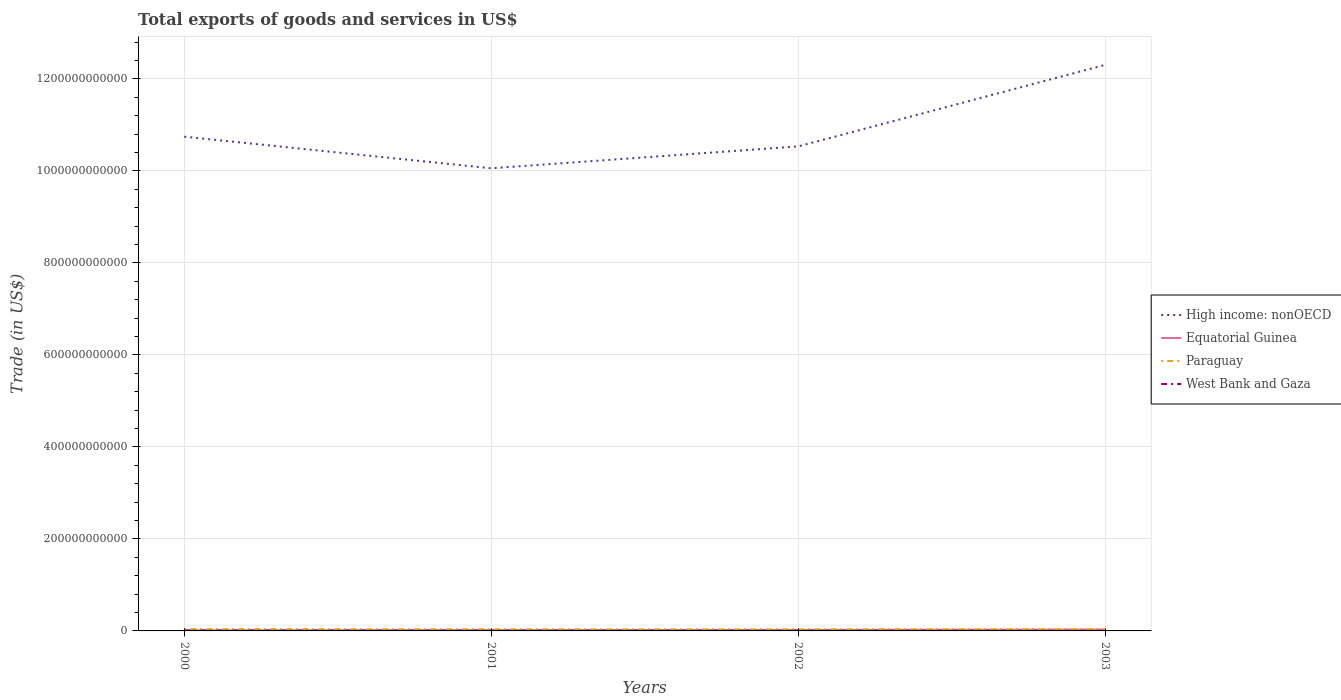Does the line corresponding to West Bank and Gaza intersect with the line corresponding to Paraguay?
Ensure brevity in your answer.  No. Is the number of lines equal to the number of legend labels?
Offer a terse response. Yes. Across all years, what is the maximum total exports of goods and services in High income: nonOECD?
Provide a short and direct response. 1.01e+12. What is the total total exports of goods and services in West Bank and Gaza in the graph?
Give a very brief answer. 4.08e+08. What is the difference between the highest and the second highest total exports of goods and services in Equatorial Guinea?
Your answer should be compact. 1.68e+09. Is the total exports of goods and services in Paraguay strictly greater than the total exports of goods and services in West Bank and Gaza over the years?
Keep it short and to the point. No. How many lines are there?
Offer a terse response. 4. What is the difference between two consecutive major ticks on the Y-axis?
Your answer should be compact. 2.00e+11. Are the values on the major ticks of Y-axis written in scientific E-notation?
Offer a terse response. No. Does the graph contain any zero values?
Ensure brevity in your answer.  No. How many legend labels are there?
Provide a short and direct response. 4. What is the title of the graph?
Your answer should be compact. Total exports of goods and services in US$. Does "Europe(all income levels)" appear as one of the legend labels in the graph?
Provide a short and direct response. No. What is the label or title of the X-axis?
Make the answer very short. Years. What is the label or title of the Y-axis?
Provide a succinct answer. Trade (in US$). What is the Trade (in US$) of High income: nonOECD in 2000?
Give a very brief answer. 1.07e+12. What is the Trade (in US$) of Equatorial Guinea in 2000?
Ensure brevity in your answer.  1.28e+09. What is the Trade (in US$) of Paraguay in 2000?
Ensure brevity in your answer.  3.84e+09. What is the Trade (in US$) in West Bank and Gaza in 2000?
Give a very brief answer. 8.86e+08. What is the Trade (in US$) of High income: nonOECD in 2001?
Provide a short and direct response. 1.01e+12. What is the Trade (in US$) in Equatorial Guinea in 2001?
Offer a very short reply. 1.82e+09. What is the Trade (in US$) in Paraguay in 2001?
Ensure brevity in your answer.  3.46e+09. What is the Trade (in US$) in West Bank and Gaza in 2001?
Your response must be concise. 6.17e+08. What is the Trade (in US$) in High income: nonOECD in 2002?
Ensure brevity in your answer.  1.05e+12. What is the Trade (in US$) in Equatorial Guinea in 2002?
Ensure brevity in your answer.  2.21e+09. What is the Trade (in US$) in Paraguay in 2002?
Provide a short and direct response. 3.40e+09. What is the Trade (in US$) of West Bank and Gaza in 2002?
Your response must be concise. 4.78e+08. What is the Trade (in US$) of High income: nonOECD in 2003?
Your response must be concise. 1.23e+12. What is the Trade (in US$) of Equatorial Guinea in 2003?
Offer a very short reply. 2.95e+09. What is the Trade (in US$) in Paraguay in 2003?
Provide a short and direct response. 3.63e+09. What is the Trade (in US$) of West Bank and Gaza in 2003?
Offer a terse response. 5.14e+08. Across all years, what is the maximum Trade (in US$) in High income: nonOECD?
Give a very brief answer. 1.23e+12. Across all years, what is the maximum Trade (in US$) in Equatorial Guinea?
Give a very brief answer. 2.95e+09. Across all years, what is the maximum Trade (in US$) of Paraguay?
Your response must be concise. 3.84e+09. Across all years, what is the maximum Trade (in US$) of West Bank and Gaza?
Your response must be concise. 8.86e+08. Across all years, what is the minimum Trade (in US$) in High income: nonOECD?
Make the answer very short. 1.01e+12. Across all years, what is the minimum Trade (in US$) in Equatorial Guinea?
Offer a terse response. 1.28e+09. Across all years, what is the minimum Trade (in US$) in Paraguay?
Keep it short and to the point. 3.40e+09. Across all years, what is the minimum Trade (in US$) of West Bank and Gaza?
Your answer should be very brief. 4.78e+08. What is the total Trade (in US$) of High income: nonOECD in the graph?
Offer a very short reply. 4.36e+12. What is the total Trade (in US$) of Equatorial Guinea in the graph?
Your response must be concise. 8.26e+09. What is the total Trade (in US$) of Paraguay in the graph?
Ensure brevity in your answer.  1.43e+1. What is the total Trade (in US$) of West Bank and Gaza in the graph?
Your response must be concise. 2.49e+09. What is the difference between the Trade (in US$) of High income: nonOECD in 2000 and that in 2001?
Your answer should be compact. 6.87e+1. What is the difference between the Trade (in US$) of Equatorial Guinea in 2000 and that in 2001?
Provide a short and direct response. -5.41e+08. What is the difference between the Trade (in US$) of Paraguay in 2000 and that in 2001?
Provide a succinct answer. 3.80e+08. What is the difference between the Trade (in US$) of West Bank and Gaza in 2000 and that in 2001?
Provide a succinct answer. 2.69e+08. What is the difference between the Trade (in US$) of High income: nonOECD in 2000 and that in 2002?
Your answer should be compact. 2.11e+1. What is the difference between the Trade (in US$) of Equatorial Guinea in 2000 and that in 2002?
Provide a short and direct response. -9.32e+08. What is the difference between the Trade (in US$) of Paraguay in 2000 and that in 2002?
Your answer should be very brief. 4.36e+08. What is the difference between the Trade (in US$) of West Bank and Gaza in 2000 and that in 2002?
Give a very brief answer. 4.08e+08. What is the difference between the Trade (in US$) in High income: nonOECD in 2000 and that in 2003?
Your answer should be compact. -1.56e+11. What is the difference between the Trade (in US$) of Equatorial Guinea in 2000 and that in 2003?
Provide a short and direct response. -1.68e+09. What is the difference between the Trade (in US$) of Paraguay in 2000 and that in 2003?
Keep it short and to the point. 2.13e+08. What is the difference between the Trade (in US$) in West Bank and Gaza in 2000 and that in 2003?
Make the answer very short. 3.72e+08. What is the difference between the Trade (in US$) of High income: nonOECD in 2001 and that in 2002?
Provide a short and direct response. -4.76e+1. What is the difference between the Trade (in US$) of Equatorial Guinea in 2001 and that in 2002?
Your answer should be compact. -3.91e+08. What is the difference between the Trade (in US$) of Paraguay in 2001 and that in 2002?
Your response must be concise. 5.65e+07. What is the difference between the Trade (in US$) in West Bank and Gaza in 2001 and that in 2002?
Ensure brevity in your answer.  1.39e+08. What is the difference between the Trade (in US$) of High income: nonOECD in 2001 and that in 2003?
Offer a terse response. -2.25e+11. What is the difference between the Trade (in US$) in Equatorial Guinea in 2001 and that in 2003?
Provide a succinct answer. -1.14e+09. What is the difference between the Trade (in US$) in Paraguay in 2001 and that in 2003?
Ensure brevity in your answer.  -1.67e+08. What is the difference between the Trade (in US$) of West Bank and Gaza in 2001 and that in 2003?
Keep it short and to the point. 1.03e+08. What is the difference between the Trade (in US$) of High income: nonOECD in 2002 and that in 2003?
Give a very brief answer. -1.77e+11. What is the difference between the Trade (in US$) in Equatorial Guinea in 2002 and that in 2003?
Provide a short and direct response. -7.44e+08. What is the difference between the Trade (in US$) of Paraguay in 2002 and that in 2003?
Your response must be concise. -2.23e+08. What is the difference between the Trade (in US$) in West Bank and Gaza in 2002 and that in 2003?
Your answer should be very brief. -3.59e+07. What is the difference between the Trade (in US$) of High income: nonOECD in 2000 and the Trade (in US$) of Equatorial Guinea in 2001?
Your response must be concise. 1.07e+12. What is the difference between the Trade (in US$) in High income: nonOECD in 2000 and the Trade (in US$) in Paraguay in 2001?
Ensure brevity in your answer.  1.07e+12. What is the difference between the Trade (in US$) in High income: nonOECD in 2000 and the Trade (in US$) in West Bank and Gaza in 2001?
Your answer should be very brief. 1.07e+12. What is the difference between the Trade (in US$) in Equatorial Guinea in 2000 and the Trade (in US$) in Paraguay in 2001?
Offer a very short reply. -2.18e+09. What is the difference between the Trade (in US$) in Equatorial Guinea in 2000 and the Trade (in US$) in West Bank and Gaza in 2001?
Ensure brevity in your answer.  6.60e+08. What is the difference between the Trade (in US$) in Paraguay in 2000 and the Trade (in US$) in West Bank and Gaza in 2001?
Keep it short and to the point. 3.22e+09. What is the difference between the Trade (in US$) in High income: nonOECD in 2000 and the Trade (in US$) in Equatorial Guinea in 2002?
Your response must be concise. 1.07e+12. What is the difference between the Trade (in US$) of High income: nonOECD in 2000 and the Trade (in US$) of Paraguay in 2002?
Your answer should be compact. 1.07e+12. What is the difference between the Trade (in US$) of High income: nonOECD in 2000 and the Trade (in US$) of West Bank and Gaza in 2002?
Your answer should be very brief. 1.07e+12. What is the difference between the Trade (in US$) of Equatorial Guinea in 2000 and the Trade (in US$) of Paraguay in 2002?
Your response must be concise. -2.13e+09. What is the difference between the Trade (in US$) of Equatorial Guinea in 2000 and the Trade (in US$) of West Bank and Gaza in 2002?
Your answer should be very brief. 7.99e+08. What is the difference between the Trade (in US$) in Paraguay in 2000 and the Trade (in US$) in West Bank and Gaza in 2002?
Your response must be concise. 3.36e+09. What is the difference between the Trade (in US$) of High income: nonOECD in 2000 and the Trade (in US$) of Equatorial Guinea in 2003?
Provide a succinct answer. 1.07e+12. What is the difference between the Trade (in US$) in High income: nonOECD in 2000 and the Trade (in US$) in Paraguay in 2003?
Ensure brevity in your answer.  1.07e+12. What is the difference between the Trade (in US$) in High income: nonOECD in 2000 and the Trade (in US$) in West Bank and Gaza in 2003?
Keep it short and to the point. 1.07e+12. What is the difference between the Trade (in US$) of Equatorial Guinea in 2000 and the Trade (in US$) of Paraguay in 2003?
Provide a short and direct response. -2.35e+09. What is the difference between the Trade (in US$) in Equatorial Guinea in 2000 and the Trade (in US$) in West Bank and Gaza in 2003?
Provide a short and direct response. 7.63e+08. What is the difference between the Trade (in US$) in Paraguay in 2000 and the Trade (in US$) in West Bank and Gaza in 2003?
Make the answer very short. 3.33e+09. What is the difference between the Trade (in US$) of High income: nonOECD in 2001 and the Trade (in US$) of Equatorial Guinea in 2002?
Provide a short and direct response. 1.00e+12. What is the difference between the Trade (in US$) of High income: nonOECD in 2001 and the Trade (in US$) of Paraguay in 2002?
Provide a short and direct response. 1.00e+12. What is the difference between the Trade (in US$) in High income: nonOECD in 2001 and the Trade (in US$) in West Bank and Gaza in 2002?
Ensure brevity in your answer.  1.01e+12. What is the difference between the Trade (in US$) of Equatorial Guinea in 2001 and the Trade (in US$) of Paraguay in 2002?
Your answer should be very brief. -1.59e+09. What is the difference between the Trade (in US$) of Equatorial Guinea in 2001 and the Trade (in US$) of West Bank and Gaza in 2002?
Your answer should be very brief. 1.34e+09. What is the difference between the Trade (in US$) of Paraguay in 2001 and the Trade (in US$) of West Bank and Gaza in 2002?
Ensure brevity in your answer.  2.98e+09. What is the difference between the Trade (in US$) in High income: nonOECD in 2001 and the Trade (in US$) in Equatorial Guinea in 2003?
Provide a short and direct response. 1.00e+12. What is the difference between the Trade (in US$) in High income: nonOECD in 2001 and the Trade (in US$) in Paraguay in 2003?
Your answer should be very brief. 1.00e+12. What is the difference between the Trade (in US$) of High income: nonOECD in 2001 and the Trade (in US$) of West Bank and Gaza in 2003?
Provide a short and direct response. 1.01e+12. What is the difference between the Trade (in US$) of Equatorial Guinea in 2001 and the Trade (in US$) of Paraguay in 2003?
Ensure brevity in your answer.  -1.81e+09. What is the difference between the Trade (in US$) of Equatorial Guinea in 2001 and the Trade (in US$) of West Bank and Gaza in 2003?
Ensure brevity in your answer.  1.30e+09. What is the difference between the Trade (in US$) of Paraguay in 2001 and the Trade (in US$) of West Bank and Gaza in 2003?
Your answer should be compact. 2.95e+09. What is the difference between the Trade (in US$) in High income: nonOECD in 2002 and the Trade (in US$) in Equatorial Guinea in 2003?
Your answer should be compact. 1.05e+12. What is the difference between the Trade (in US$) in High income: nonOECD in 2002 and the Trade (in US$) in Paraguay in 2003?
Make the answer very short. 1.05e+12. What is the difference between the Trade (in US$) of High income: nonOECD in 2002 and the Trade (in US$) of West Bank and Gaza in 2003?
Your response must be concise. 1.05e+12. What is the difference between the Trade (in US$) of Equatorial Guinea in 2002 and the Trade (in US$) of Paraguay in 2003?
Keep it short and to the point. -1.42e+09. What is the difference between the Trade (in US$) of Equatorial Guinea in 2002 and the Trade (in US$) of West Bank and Gaza in 2003?
Your answer should be very brief. 1.70e+09. What is the difference between the Trade (in US$) of Paraguay in 2002 and the Trade (in US$) of West Bank and Gaza in 2003?
Offer a very short reply. 2.89e+09. What is the average Trade (in US$) in High income: nonOECD per year?
Offer a very short reply. 1.09e+12. What is the average Trade (in US$) in Equatorial Guinea per year?
Ensure brevity in your answer.  2.06e+09. What is the average Trade (in US$) in Paraguay per year?
Provide a succinct answer. 3.58e+09. What is the average Trade (in US$) in West Bank and Gaza per year?
Provide a succinct answer. 6.24e+08. In the year 2000, what is the difference between the Trade (in US$) of High income: nonOECD and Trade (in US$) of Equatorial Guinea?
Your answer should be very brief. 1.07e+12. In the year 2000, what is the difference between the Trade (in US$) in High income: nonOECD and Trade (in US$) in Paraguay?
Give a very brief answer. 1.07e+12. In the year 2000, what is the difference between the Trade (in US$) in High income: nonOECD and Trade (in US$) in West Bank and Gaza?
Keep it short and to the point. 1.07e+12. In the year 2000, what is the difference between the Trade (in US$) of Equatorial Guinea and Trade (in US$) of Paraguay?
Offer a terse response. -2.56e+09. In the year 2000, what is the difference between the Trade (in US$) of Equatorial Guinea and Trade (in US$) of West Bank and Gaza?
Provide a short and direct response. 3.91e+08. In the year 2000, what is the difference between the Trade (in US$) in Paraguay and Trade (in US$) in West Bank and Gaza?
Keep it short and to the point. 2.95e+09. In the year 2001, what is the difference between the Trade (in US$) in High income: nonOECD and Trade (in US$) in Equatorial Guinea?
Provide a succinct answer. 1.00e+12. In the year 2001, what is the difference between the Trade (in US$) of High income: nonOECD and Trade (in US$) of Paraguay?
Keep it short and to the point. 1.00e+12. In the year 2001, what is the difference between the Trade (in US$) in High income: nonOECD and Trade (in US$) in West Bank and Gaza?
Provide a succinct answer. 1.01e+12. In the year 2001, what is the difference between the Trade (in US$) of Equatorial Guinea and Trade (in US$) of Paraguay?
Ensure brevity in your answer.  -1.64e+09. In the year 2001, what is the difference between the Trade (in US$) in Equatorial Guinea and Trade (in US$) in West Bank and Gaza?
Provide a succinct answer. 1.20e+09. In the year 2001, what is the difference between the Trade (in US$) in Paraguay and Trade (in US$) in West Bank and Gaza?
Keep it short and to the point. 2.84e+09. In the year 2002, what is the difference between the Trade (in US$) of High income: nonOECD and Trade (in US$) of Equatorial Guinea?
Your answer should be very brief. 1.05e+12. In the year 2002, what is the difference between the Trade (in US$) in High income: nonOECD and Trade (in US$) in Paraguay?
Your answer should be very brief. 1.05e+12. In the year 2002, what is the difference between the Trade (in US$) in High income: nonOECD and Trade (in US$) in West Bank and Gaza?
Make the answer very short. 1.05e+12. In the year 2002, what is the difference between the Trade (in US$) in Equatorial Guinea and Trade (in US$) in Paraguay?
Ensure brevity in your answer.  -1.19e+09. In the year 2002, what is the difference between the Trade (in US$) of Equatorial Guinea and Trade (in US$) of West Bank and Gaza?
Ensure brevity in your answer.  1.73e+09. In the year 2002, what is the difference between the Trade (in US$) in Paraguay and Trade (in US$) in West Bank and Gaza?
Keep it short and to the point. 2.92e+09. In the year 2003, what is the difference between the Trade (in US$) in High income: nonOECD and Trade (in US$) in Equatorial Guinea?
Offer a very short reply. 1.23e+12. In the year 2003, what is the difference between the Trade (in US$) in High income: nonOECD and Trade (in US$) in Paraguay?
Ensure brevity in your answer.  1.23e+12. In the year 2003, what is the difference between the Trade (in US$) of High income: nonOECD and Trade (in US$) of West Bank and Gaza?
Your answer should be compact. 1.23e+12. In the year 2003, what is the difference between the Trade (in US$) in Equatorial Guinea and Trade (in US$) in Paraguay?
Give a very brief answer. -6.73e+08. In the year 2003, what is the difference between the Trade (in US$) in Equatorial Guinea and Trade (in US$) in West Bank and Gaza?
Ensure brevity in your answer.  2.44e+09. In the year 2003, what is the difference between the Trade (in US$) in Paraguay and Trade (in US$) in West Bank and Gaza?
Keep it short and to the point. 3.11e+09. What is the ratio of the Trade (in US$) of High income: nonOECD in 2000 to that in 2001?
Make the answer very short. 1.07. What is the ratio of the Trade (in US$) of Equatorial Guinea in 2000 to that in 2001?
Provide a short and direct response. 0.7. What is the ratio of the Trade (in US$) of Paraguay in 2000 to that in 2001?
Provide a short and direct response. 1.11. What is the ratio of the Trade (in US$) of West Bank and Gaza in 2000 to that in 2001?
Keep it short and to the point. 1.44. What is the ratio of the Trade (in US$) in High income: nonOECD in 2000 to that in 2002?
Offer a terse response. 1.02. What is the ratio of the Trade (in US$) of Equatorial Guinea in 2000 to that in 2002?
Give a very brief answer. 0.58. What is the ratio of the Trade (in US$) in Paraguay in 2000 to that in 2002?
Offer a terse response. 1.13. What is the ratio of the Trade (in US$) of West Bank and Gaza in 2000 to that in 2002?
Your answer should be compact. 1.85. What is the ratio of the Trade (in US$) of High income: nonOECD in 2000 to that in 2003?
Provide a succinct answer. 0.87. What is the ratio of the Trade (in US$) of Equatorial Guinea in 2000 to that in 2003?
Give a very brief answer. 0.43. What is the ratio of the Trade (in US$) of Paraguay in 2000 to that in 2003?
Offer a terse response. 1.06. What is the ratio of the Trade (in US$) in West Bank and Gaza in 2000 to that in 2003?
Offer a terse response. 1.72. What is the ratio of the Trade (in US$) of High income: nonOECD in 2001 to that in 2002?
Give a very brief answer. 0.95. What is the ratio of the Trade (in US$) in Equatorial Guinea in 2001 to that in 2002?
Offer a very short reply. 0.82. What is the ratio of the Trade (in US$) in Paraguay in 2001 to that in 2002?
Keep it short and to the point. 1.02. What is the ratio of the Trade (in US$) of West Bank and Gaza in 2001 to that in 2002?
Give a very brief answer. 1.29. What is the ratio of the Trade (in US$) of High income: nonOECD in 2001 to that in 2003?
Give a very brief answer. 0.82. What is the ratio of the Trade (in US$) of Equatorial Guinea in 2001 to that in 2003?
Your answer should be compact. 0.62. What is the ratio of the Trade (in US$) of Paraguay in 2001 to that in 2003?
Your answer should be compact. 0.95. What is the ratio of the Trade (in US$) of West Bank and Gaza in 2001 to that in 2003?
Ensure brevity in your answer.  1.2. What is the ratio of the Trade (in US$) in High income: nonOECD in 2002 to that in 2003?
Offer a terse response. 0.86. What is the ratio of the Trade (in US$) of Equatorial Guinea in 2002 to that in 2003?
Your response must be concise. 0.75. What is the ratio of the Trade (in US$) of Paraguay in 2002 to that in 2003?
Your answer should be very brief. 0.94. What is the ratio of the Trade (in US$) of West Bank and Gaza in 2002 to that in 2003?
Keep it short and to the point. 0.93. What is the difference between the highest and the second highest Trade (in US$) of High income: nonOECD?
Make the answer very short. 1.56e+11. What is the difference between the highest and the second highest Trade (in US$) of Equatorial Guinea?
Your answer should be compact. 7.44e+08. What is the difference between the highest and the second highest Trade (in US$) in Paraguay?
Provide a short and direct response. 2.13e+08. What is the difference between the highest and the second highest Trade (in US$) of West Bank and Gaza?
Provide a succinct answer. 2.69e+08. What is the difference between the highest and the lowest Trade (in US$) in High income: nonOECD?
Provide a short and direct response. 2.25e+11. What is the difference between the highest and the lowest Trade (in US$) of Equatorial Guinea?
Give a very brief answer. 1.68e+09. What is the difference between the highest and the lowest Trade (in US$) of Paraguay?
Ensure brevity in your answer.  4.36e+08. What is the difference between the highest and the lowest Trade (in US$) of West Bank and Gaza?
Provide a succinct answer. 4.08e+08. 